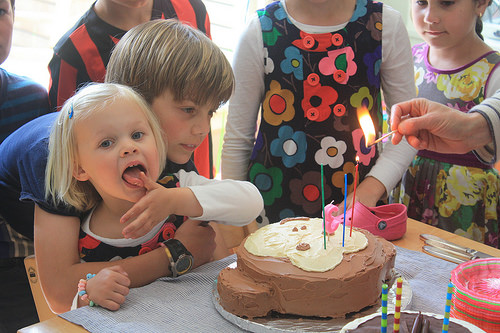<image>
Can you confirm if the candle is on the cake? Yes. Looking at the image, I can see the candle is positioned on top of the cake, with the cake providing support. 